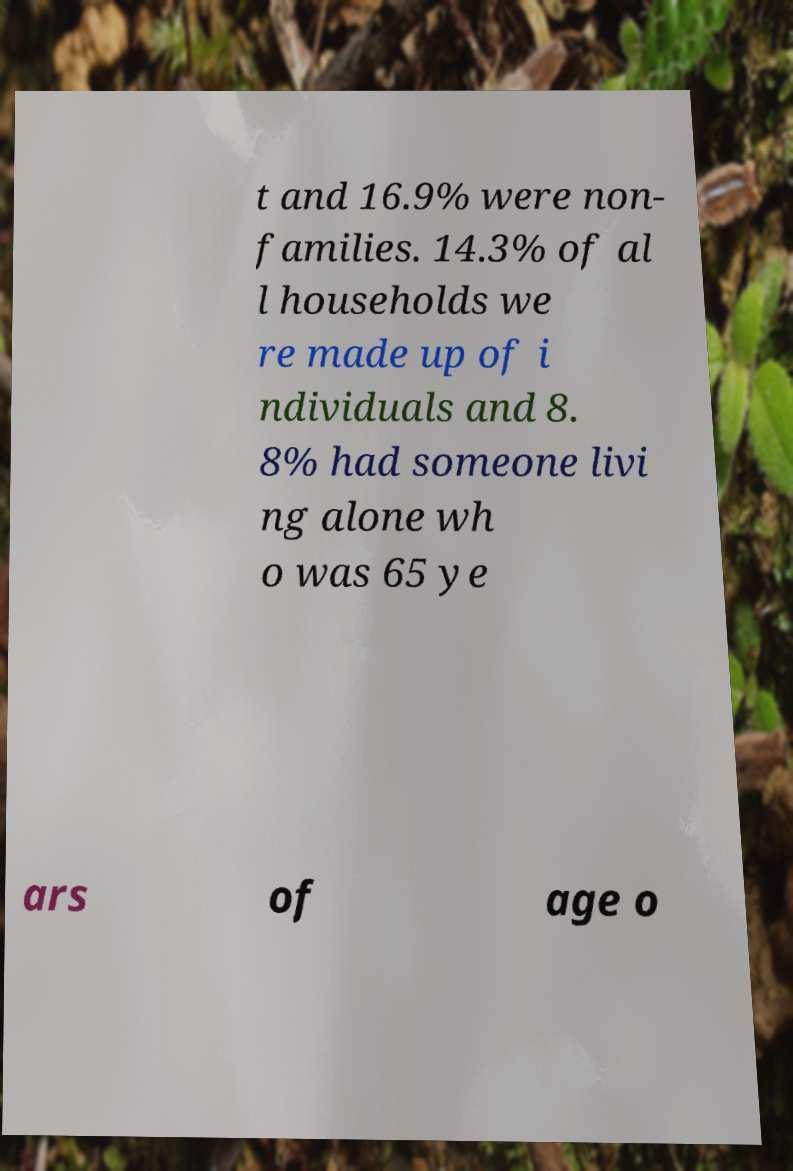Can you read and provide the text displayed in the image?This photo seems to have some interesting text. Can you extract and type it out for me? t and 16.9% were non- families. 14.3% of al l households we re made up of i ndividuals and 8. 8% had someone livi ng alone wh o was 65 ye ars of age o 